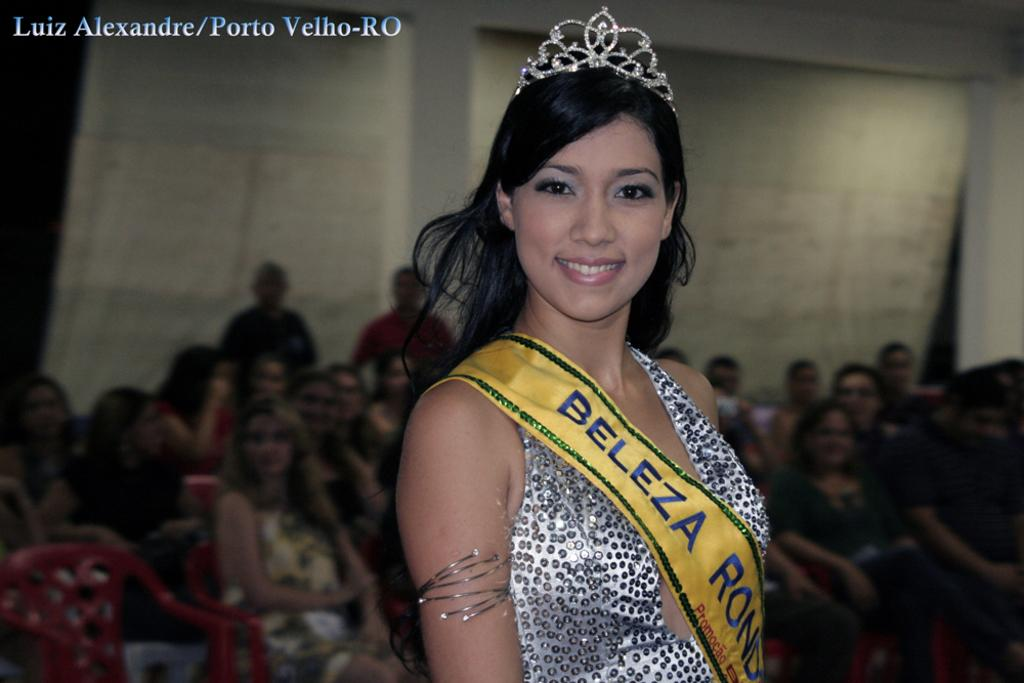Who is the main subject in the image? There is a woman in the image. What is the woman wearing? The woman is wearing a dress. Can you describe the woman's hair? The woman has long hair. What accessory is the woman wearing on her head? The woman is wearing a crown on her head. What can be seen in the background of the image? There is a group of people sitting on chairs in the background of the image, and there are curtains visible as well. What type of cloth is the woman using to sense the environment in the image? There is no cloth present in the image that the woman is using to sense the environment. Is there a notebook visible in the image? No, there is no notebook present in the image. 